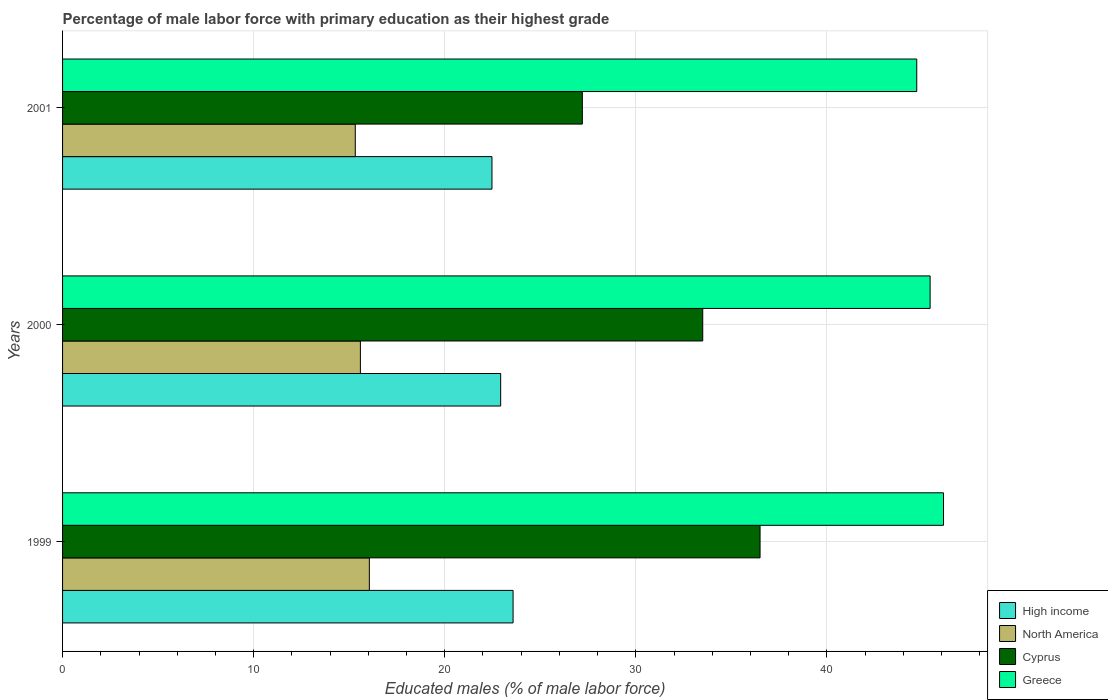How many groups of bars are there?
Ensure brevity in your answer.  3. Are the number of bars per tick equal to the number of legend labels?
Ensure brevity in your answer.  Yes. How many bars are there on the 1st tick from the bottom?
Your response must be concise. 4. In how many cases, is the number of bars for a given year not equal to the number of legend labels?
Your answer should be very brief. 0. What is the percentage of male labor force with primary education in Cyprus in 1999?
Your answer should be very brief. 36.5. Across all years, what is the maximum percentage of male labor force with primary education in High income?
Your answer should be very brief. 23.58. Across all years, what is the minimum percentage of male labor force with primary education in Greece?
Offer a very short reply. 44.7. In which year was the percentage of male labor force with primary education in High income maximum?
Your response must be concise. 1999. What is the total percentage of male labor force with primary education in Cyprus in the graph?
Offer a very short reply. 97.2. What is the difference between the percentage of male labor force with primary education in High income in 1999 and that in 2000?
Ensure brevity in your answer.  0.65. What is the difference between the percentage of male labor force with primary education in Cyprus in 2000 and the percentage of male labor force with primary education in High income in 1999?
Make the answer very short. 9.92. What is the average percentage of male labor force with primary education in North America per year?
Your answer should be very brief. 15.65. In the year 2000, what is the difference between the percentage of male labor force with primary education in Greece and percentage of male labor force with primary education in Cyprus?
Provide a succinct answer. 11.9. In how many years, is the percentage of male labor force with primary education in High income greater than 42 %?
Keep it short and to the point. 0. What is the ratio of the percentage of male labor force with primary education in Greece in 1999 to that in 2000?
Ensure brevity in your answer.  1.02. Is the percentage of male labor force with primary education in High income in 1999 less than that in 2001?
Offer a very short reply. No. Is the difference between the percentage of male labor force with primary education in Greece in 1999 and 2001 greater than the difference between the percentage of male labor force with primary education in Cyprus in 1999 and 2001?
Offer a very short reply. No. What is the difference between the highest and the second highest percentage of male labor force with primary education in High income?
Provide a short and direct response. 0.65. What is the difference between the highest and the lowest percentage of male labor force with primary education in Cyprus?
Ensure brevity in your answer.  9.3. In how many years, is the percentage of male labor force with primary education in North America greater than the average percentage of male labor force with primary education in North America taken over all years?
Provide a short and direct response. 1. Is the sum of the percentage of male labor force with primary education in Greece in 1999 and 2000 greater than the maximum percentage of male labor force with primary education in Cyprus across all years?
Provide a short and direct response. Yes. Is it the case that in every year, the sum of the percentage of male labor force with primary education in Greece and percentage of male labor force with primary education in Cyprus is greater than the sum of percentage of male labor force with primary education in High income and percentage of male labor force with primary education in North America?
Your answer should be very brief. Yes. What does the 4th bar from the top in 2000 represents?
Make the answer very short. High income. How many bars are there?
Make the answer very short. 12. How many years are there in the graph?
Your answer should be compact. 3. What is the difference between two consecutive major ticks on the X-axis?
Give a very brief answer. 10. Does the graph contain any zero values?
Your answer should be compact. No. Does the graph contain grids?
Your response must be concise. Yes. How many legend labels are there?
Provide a succinct answer. 4. How are the legend labels stacked?
Your response must be concise. Vertical. What is the title of the graph?
Give a very brief answer. Percentage of male labor force with primary education as their highest grade. Does "Cambodia" appear as one of the legend labels in the graph?
Your answer should be very brief. No. What is the label or title of the X-axis?
Ensure brevity in your answer.  Educated males (% of male labor force). What is the label or title of the Y-axis?
Offer a very short reply. Years. What is the Educated males (% of male labor force) in High income in 1999?
Ensure brevity in your answer.  23.58. What is the Educated males (% of male labor force) in North America in 1999?
Offer a very short reply. 16.05. What is the Educated males (% of male labor force) in Cyprus in 1999?
Give a very brief answer. 36.5. What is the Educated males (% of male labor force) of Greece in 1999?
Keep it short and to the point. 46.1. What is the Educated males (% of male labor force) in High income in 2000?
Your answer should be very brief. 22.93. What is the Educated males (% of male labor force) in North America in 2000?
Keep it short and to the point. 15.59. What is the Educated males (% of male labor force) of Cyprus in 2000?
Your answer should be very brief. 33.5. What is the Educated males (% of male labor force) in Greece in 2000?
Provide a succinct answer. 45.4. What is the Educated males (% of male labor force) of High income in 2001?
Provide a succinct answer. 22.47. What is the Educated males (% of male labor force) of North America in 2001?
Ensure brevity in your answer.  15.32. What is the Educated males (% of male labor force) of Cyprus in 2001?
Keep it short and to the point. 27.2. What is the Educated males (% of male labor force) in Greece in 2001?
Give a very brief answer. 44.7. Across all years, what is the maximum Educated males (% of male labor force) of High income?
Ensure brevity in your answer.  23.58. Across all years, what is the maximum Educated males (% of male labor force) of North America?
Your response must be concise. 16.05. Across all years, what is the maximum Educated males (% of male labor force) of Cyprus?
Give a very brief answer. 36.5. Across all years, what is the maximum Educated males (% of male labor force) of Greece?
Your answer should be very brief. 46.1. Across all years, what is the minimum Educated males (% of male labor force) in High income?
Offer a very short reply. 22.47. Across all years, what is the minimum Educated males (% of male labor force) in North America?
Make the answer very short. 15.32. Across all years, what is the minimum Educated males (% of male labor force) of Cyprus?
Give a very brief answer. 27.2. Across all years, what is the minimum Educated males (% of male labor force) in Greece?
Give a very brief answer. 44.7. What is the total Educated males (% of male labor force) of High income in the graph?
Ensure brevity in your answer.  68.97. What is the total Educated males (% of male labor force) of North America in the graph?
Keep it short and to the point. 46.96. What is the total Educated males (% of male labor force) of Cyprus in the graph?
Offer a very short reply. 97.2. What is the total Educated males (% of male labor force) of Greece in the graph?
Your answer should be very brief. 136.2. What is the difference between the Educated males (% of male labor force) of High income in 1999 and that in 2000?
Keep it short and to the point. 0.65. What is the difference between the Educated males (% of male labor force) in North America in 1999 and that in 2000?
Give a very brief answer. 0.47. What is the difference between the Educated males (% of male labor force) in High income in 1999 and that in 2001?
Ensure brevity in your answer.  1.1. What is the difference between the Educated males (% of male labor force) in North America in 1999 and that in 2001?
Offer a very short reply. 0.74. What is the difference between the Educated males (% of male labor force) of Greece in 1999 and that in 2001?
Offer a very short reply. 1.4. What is the difference between the Educated males (% of male labor force) of High income in 2000 and that in 2001?
Your answer should be very brief. 0.46. What is the difference between the Educated males (% of male labor force) in North America in 2000 and that in 2001?
Provide a succinct answer. 0.27. What is the difference between the Educated males (% of male labor force) in High income in 1999 and the Educated males (% of male labor force) in North America in 2000?
Your answer should be compact. 7.99. What is the difference between the Educated males (% of male labor force) in High income in 1999 and the Educated males (% of male labor force) in Cyprus in 2000?
Your response must be concise. -9.92. What is the difference between the Educated males (% of male labor force) in High income in 1999 and the Educated males (% of male labor force) in Greece in 2000?
Your answer should be very brief. -21.82. What is the difference between the Educated males (% of male labor force) of North America in 1999 and the Educated males (% of male labor force) of Cyprus in 2000?
Keep it short and to the point. -17.45. What is the difference between the Educated males (% of male labor force) of North America in 1999 and the Educated males (% of male labor force) of Greece in 2000?
Offer a terse response. -29.35. What is the difference between the Educated males (% of male labor force) of Cyprus in 1999 and the Educated males (% of male labor force) of Greece in 2000?
Make the answer very short. -8.9. What is the difference between the Educated males (% of male labor force) in High income in 1999 and the Educated males (% of male labor force) in North America in 2001?
Offer a terse response. 8.26. What is the difference between the Educated males (% of male labor force) of High income in 1999 and the Educated males (% of male labor force) of Cyprus in 2001?
Make the answer very short. -3.62. What is the difference between the Educated males (% of male labor force) in High income in 1999 and the Educated males (% of male labor force) in Greece in 2001?
Offer a terse response. -21.12. What is the difference between the Educated males (% of male labor force) of North America in 1999 and the Educated males (% of male labor force) of Cyprus in 2001?
Your answer should be very brief. -11.15. What is the difference between the Educated males (% of male labor force) of North America in 1999 and the Educated males (% of male labor force) of Greece in 2001?
Your answer should be very brief. -28.65. What is the difference between the Educated males (% of male labor force) of High income in 2000 and the Educated males (% of male labor force) of North America in 2001?
Your answer should be very brief. 7.61. What is the difference between the Educated males (% of male labor force) of High income in 2000 and the Educated males (% of male labor force) of Cyprus in 2001?
Offer a terse response. -4.27. What is the difference between the Educated males (% of male labor force) of High income in 2000 and the Educated males (% of male labor force) of Greece in 2001?
Offer a very short reply. -21.77. What is the difference between the Educated males (% of male labor force) in North America in 2000 and the Educated males (% of male labor force) in Cyprus in 2001?
Ensure brevity in your answer.  -11.61. What is the difference between the Educated males (% of male labor force) of North America in 2000 and the Educated males (% of male labor force) of Greece in 2001?
Your answer should be very brief. -29.11. What is the difference between the Educated males (% of male labor force) of Cyprus in 2000 and the Educated males (% of male labor force) of Greece in 2001?
Offer a terse response. -11.2. What is the average Educated males (% of male labor force) in High income per year?
Your answer should be compact. 22.99. What is the average Educated males (% of male labor force) of North America per year?
Make the answer very short. 15.65. What is the average Educated males (% of male labor force) of Cyprus per year?
Offer a very short reply. 32.4. What is the average Educated males (% of male labor force) in Greece per year?
Offer a terse response. 45.4. In the year 1999, what is the difference between the Educated males (% of male labor force) in High income and Educated males (% of male labor force) in North America?
Offer a terse response. 7.52. In the year 1999, what is the difference between the Educated males (% of male labor force) of High income and Educated males (% of male labor force) of Cyprus?
Your answer should be very brief. -12.92. In the year 1999, what is the difference between the Educated males (% of male labor force) of High income and Educated males (% of male labor force) of Greece?
Your answer should be very brief. -22.52. In the year 1999, what is the difference between the Educated males (% of male labor force) of North America and Educated males (% of male labor force) of Cyprus?
Ensure brevity in your answer.  -20.45. In the year 1999, what is the difference between the Educated males (% of male labor force) in North America and Educated males (% of male labor force) in Greece?
Keep it short and to the point. -30.05. In the year 1999, what is the difference between the Educated males (% of male labor force) in Cyprus and Educated males (% of male labor force) in Greece?
Offer a very short reply. -9.6. In the year 2000, what is the difference between the Educated males (% of male labor force) in High income and Educated males (% of male labor force) in North America?
Give a very brief answer. 7.34. In the year 2000, what is the difference between the Educated males (% of male labor force) in High income and Educated males (% of male labor force) in Cyprus?
Your response must be concise. -10.57. In the year 2000, what is the difference between the Educated males (% of male labor force) in High income and Educated males (% of male labor force) in Greece?
Provide a succinct answer. -22.47. In the year 2000, what is the difference between the Educated males (% of male labor force) in North America and Educated males (% of male labor force) in Cyprus?
Keep it short and to the point. -17.91. In the year 2000, what is the difference between the Educated males (% of male labor force) in North America and Educated males (% of male labor force) in Greece?
Ensure brevity in your answer.  -29.81. In the year 2000, what is the difference between the Educated males (% of male labor force) of Cyprus and Educated males (% of male labor force) of Greece?
Offer a terse response. -11.9. In the year 2001, what is the difference between the Educated males (% of male labor force) of High income and Educated males (% of male labor force) of North America?
Your answer should be compact. 7.15. In the year 2001, what is the difference between the Educated males (% of male labor force) in High income and Educated males (% of male labor force) in Cyprus?
Offer a very short reply. -4.73. In the year 2001, what is the difference between the Educated males (% of male labor force) of High income and Educated males (% of male labor force) of Greece?
Offer a terse response. -22.23. In the year 2001, what is the difference between the Educated males (% of male labor force) in North America and Educated males (% of male labor force) in Cyprus?
Offer a terse response. -11.88. In the year 2001, what is the difference between the Educated males (% of male labor force) of North America and Educated males (% of male labor force) of Greece?
Offer a terse response. -29.38. In the year 2001, what is the difference between the Educated males (% of male labor force) of Cyprus and Educated males (% of male labor force) of Greece?
Provide a short and direct response. -17.5. What is the ratio of the Educated males (% of male labor force) in High income in 1999 to that in 2000?
Provide a short and direct response. 1.03. What is the ratio of the Educated males (% of male labor force) in North America in 1999 to that in 2000?
Offer a very short reply. 1.03. What is the ratio of the Educated males (% of male labor force) of Cyprus in 1999 to that in 2000?
Your response must be concise. 1.09. What is the ratio of the Educated males (% of male labor force) in Greece in 1999 to that in 2000?
Your response must be concise. 1.02. What is the ratio of the Educated males (% of male labor force) of High income in 1999 to that in 2001?
Offer a very short reply. 1.05. What is the ratio of the Educated males (% of male labor force) in North America in 1999 to that in 2001?
Give a very brief answer. 1.05. What is the ratio of the Educated males (% of male labor force) in Cyprus in 1999 to that in 2001?
Offer a terse response. 1.34. What is the ratio of the Educated males (% of male labor force) of Greece in 1999 to that in 2001?
Keep it short and to the point. 1.03. What is the ratio of the Educated males (% of male labor force) in High income in 2000 to that in 2001?
Make the answer very short. 1.02. What is the ratio of the Educated males (% of male labor force) of North America in 2000 to that in 2001?
Your answer should be very brief. 1.02. What is the ratio of the Educated males (% of male labor force) of Cyprus in 2000 to that in 2001?
Your answer should be compact. 1.23. What is the ratio of the Educated males (% of male labor force) of Greece in 2000 to that in 2001?
Provide a short and direct response. 1.02. What is the difference between the highest and the second highest Educated males (% of male labor force) of High income?
Offer a very short reply. 0.65. What is the difference between the highest and the second highest Educated males (% of male labor force) in North America?
Keep it short and to the point. 0.47. What is the difference between the highest and the second highest Educated males (% of male labor force) in Greece?
Your answer should be compact. 0.7. What is the difference between the highest and the lowest Educated males (% of male labor force) in High income?
Keep it short and to the point. 1.1. What is the difference between the highest and the lowest Educated males (% of male labor force) in North America?
Offer a terse response. 0.74. What is the difference between the highest and the lowest Educated males (% of male labor force) of Cyprus?
Provide a succinct answer. 9.3. What is the difference between the highest and the lowest Educated males (% of male labor force) in Greece?
Your answer should be very brief. 1.4. 